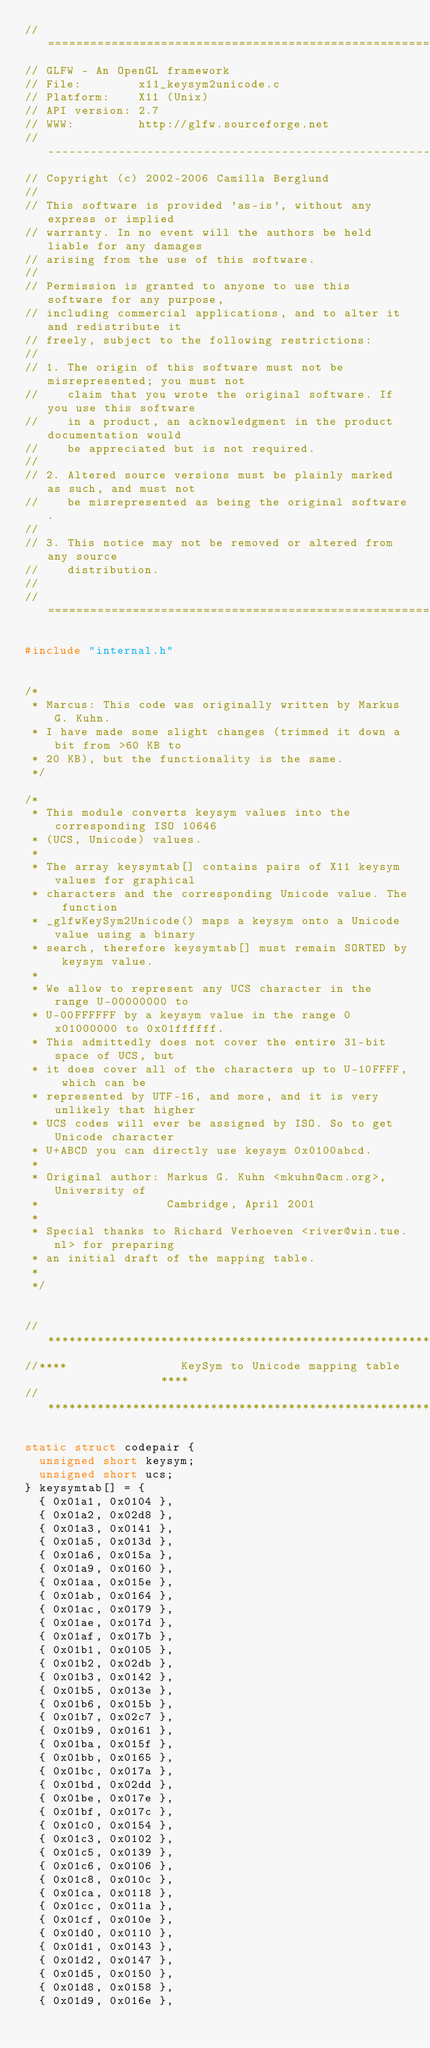<code> <loc_0><loc_0><loc_500><loc_500><_C_>//========================================================================
// GLFW - An OpenGL framework
// File:        x11_keysym2unicode.c
// Platform:    X11 (Unix)
// API version: 2.7
// WWW:         http://glfw.sourceforge.net
//------------------------------------------------------------------------
// Copyright (c) 2002-2006 Camilla Berglund
//
// This software is provided 'as-is', without any express or implied
// warranty. In no event will the authors be held liable for any damages
// arising from the use of this software.
//
// Permission is granted to anyone to use this software for any purpose,
// including commercial applications, and to alter it and redistribute it
// freely, subject to the following restrictions:
//
// 1. The origin of this software must not be misrepresented; you must not
//    claim that you wrote the original software. If you use this software
//    in a product, an acknowledgment in the product documentation would
//    be appreciated but is not required.
//
// 2. Altered source versions must be plainly marked as such, and must not
//    be misrepresented as being the original software.
//
// 3. This notice may not be removed or altered from any source
//    distribution.
//
//========================================================================

#include "internal.h"


/*
 * Marcus: This code was originally written by Markus G. Kuhn.
 * I have made some slight changes (trimmed it down a bit from >60 KB to
 * 20 KB), but the functionality is the same.
 */

/*
 * This module converts keysym values into the corresponding ISO 10646
 * (UCS, Unicode) values.
 *
 * The array keysymtab[] contains pairs of X11 keysym values for graphical
 * characters and the corresponding Unicode value. The function
 * _glfwKeySym2Unicode() maps a keysym onto a Unicode value using a binary
 * search, therefore keysymtab[] must remain SORTED by keysym value.
 *
 * We allow to represent any UCS character in the range U-00000000 to
 * U-00FFFFFF by a keysym value in the range 0x01000000 to 0x01ffffff.
 * This admittedly does not cover the entire 31-bit space of UCS, but
 * it does cover all of the characters up to U-10FFFF, which can be
 * represented by UTF-16, and more, and it is very unlikely that higher
 * UCS codes will ever be assigned by ISO. So to get Unicode character
 * U+ABCD you can directly use keysym 0x0100abcd.
 *
 * Original author: Markus G. Kuhn <mkuhn@acm.org>, University of
 *                  Cambridge, April 2001
 *
 * Special thanks to Richard Verhoeven <river@win.tue.nl> for preparing
 * an initial draft of the mapping table.
 *
 */


//************************************************************************
//****                KeySym to Unicode mapping table                 ****
//************************************************************************

static struct codepair {
  unsigned short keysym;
  unsigned short ucs;
} keysymtab[] = {
  { 0x01a1, 0x0104 },
  { 0x01a2, 0x02d8 },
  { 0x01a3, 0x0141 },
  { 0x01a5, 0x013d },
  { 0x01a6, 0x015a },
  { 0x01a9, 0x0160 },
  { 0x01aa, 0x015e },
  { 0x01ab, 0x0164 },
  { 0x01ac, 0x0179 },
  { 0x01ae, 0x017d },
  { 0x01af, 0x017b },
  { 0x01b1, 0x0105 },
  { 0x01b2, 0x02db },
  { 0x01b3, 0x0142 },
  { 0x01b5, 0x013e },
  { 0x01b6, 0x015b },
  { 0x01b7, 0x02c7 },
  { 0x01b9, 0x0161 },
  { 0x01ba, 0x015f },
  { 0x01bb, 0x0165 },
  { 0x01bc, 0x017a },
  { 0x01bd, 0x02dd },
  { 0x01be, 0x017e },
  { 0x01bf, 0x017c },
  { 0x01c0, 0x0154 },
  { 0x01c3, 0x0102 },
  { 0x01c5, 0x0139 },
  { 0x01c6, 0x0106 },
  { 0x01c8, 0x010c },
  { 0x01ca, 0x0118 },
  { 0x01cc, 0x011a },
  { 0x01cf, 0x010e },
  { 0x01d0, 0x0110 },
  { 0x01d1, 0x0143 },
  { 0x01d2, 0x0147 },
  { 0x01d5, 0x0150 },
  { 0x01d8, 0x0158 },
  { 0x01d9, 0x016e },</code> 